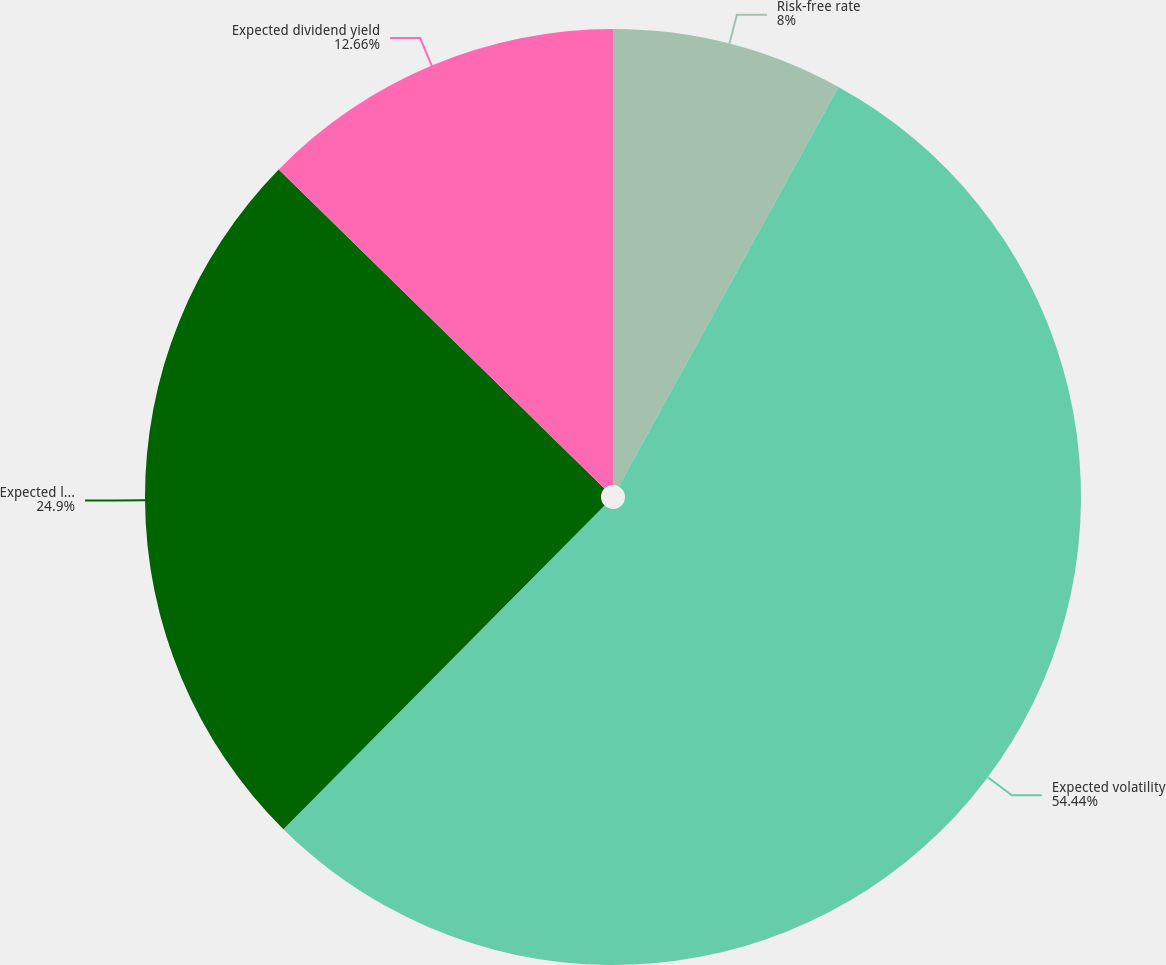Convert chart to OTSL. <chart><loc_0><loc_0><loc_500><loc_500><pie_chart><fcel>Risk-free rate<fcel>Expected volatility<fcel>Expected life (in years)<fcel>Expected dividend yield<nl><fcel>8.0%<fcel>54.43%<fcel>24.9%<fcel>12.66%<nl></chart> 